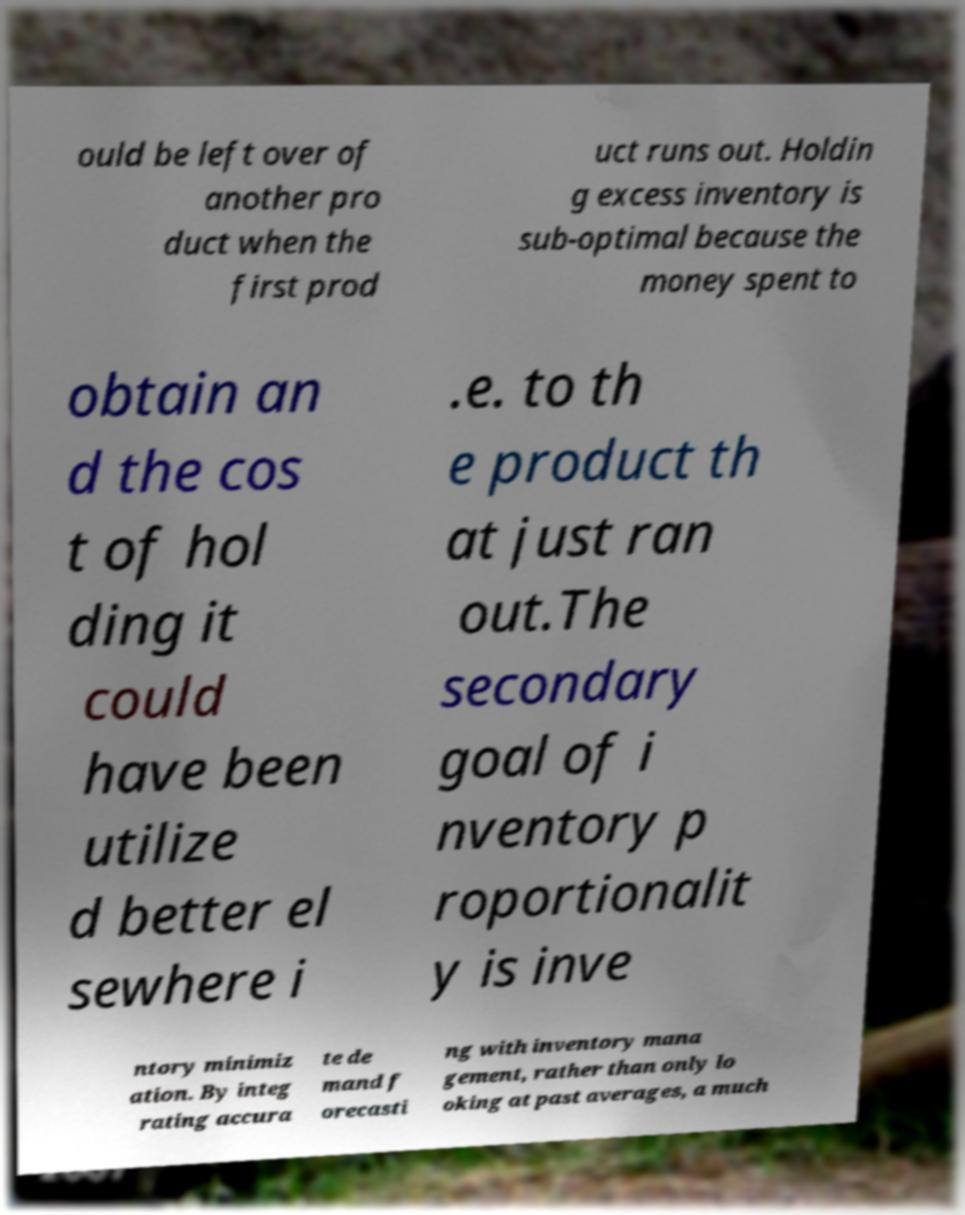There's text embedded in this image that I need extracted. Can you transcribe it verbatim? ould be left over of another pro duct when the first prod uct runs out. Holdin g excess inventory is sub-optimal because the money spent to obtain an d the cos t of hol ding it could have been utilize d better el sewhere i .e. to th e product th at just ran out.The secondary goal of i nventory p roportionalit y is inve ntory minimiz ation. By integ rating accura te de mand f orecasti ng with inventory mana gement, rather than only lo oking at past averages, a much 